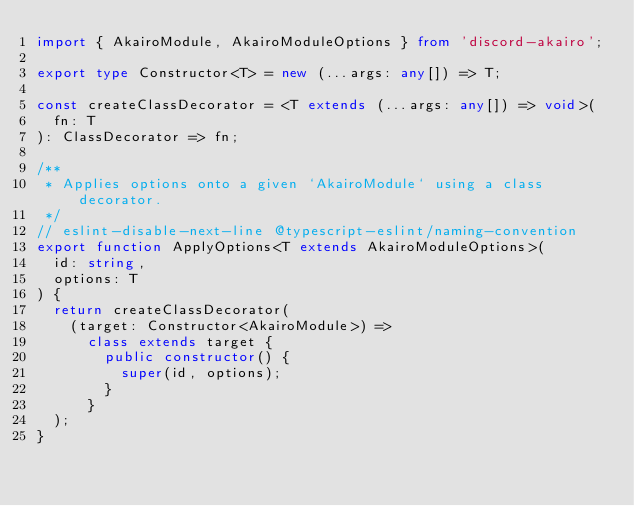<code> <loc_0><loc_0><loc_500><loc_500><_TypeScript_>import { AkairoModule, AkairoModuleOptions } from 'discord-akairo';

export type Constructor<T> = new (...args: any[]) => T;

const createClassDecorator = <T extends (...args: any[]) => void>(
  fn: T
): ClassDecorator => fn;

/**
 * Applies options onto a given `AkairoModule` using a class decorator.
 */
// eslint-disable-next-line @typescript-eslint/naming-convention
export function ApplyOptions<T extends AkairoModuleOptions>(
  id: string,
  options: T
) {
  return createClassDecorator(
    (target: Constructor<AkairoModule>) =>
      class extends target {
        public constructor() {
          super(id, options);
        }
      }
  );
}
</code> 